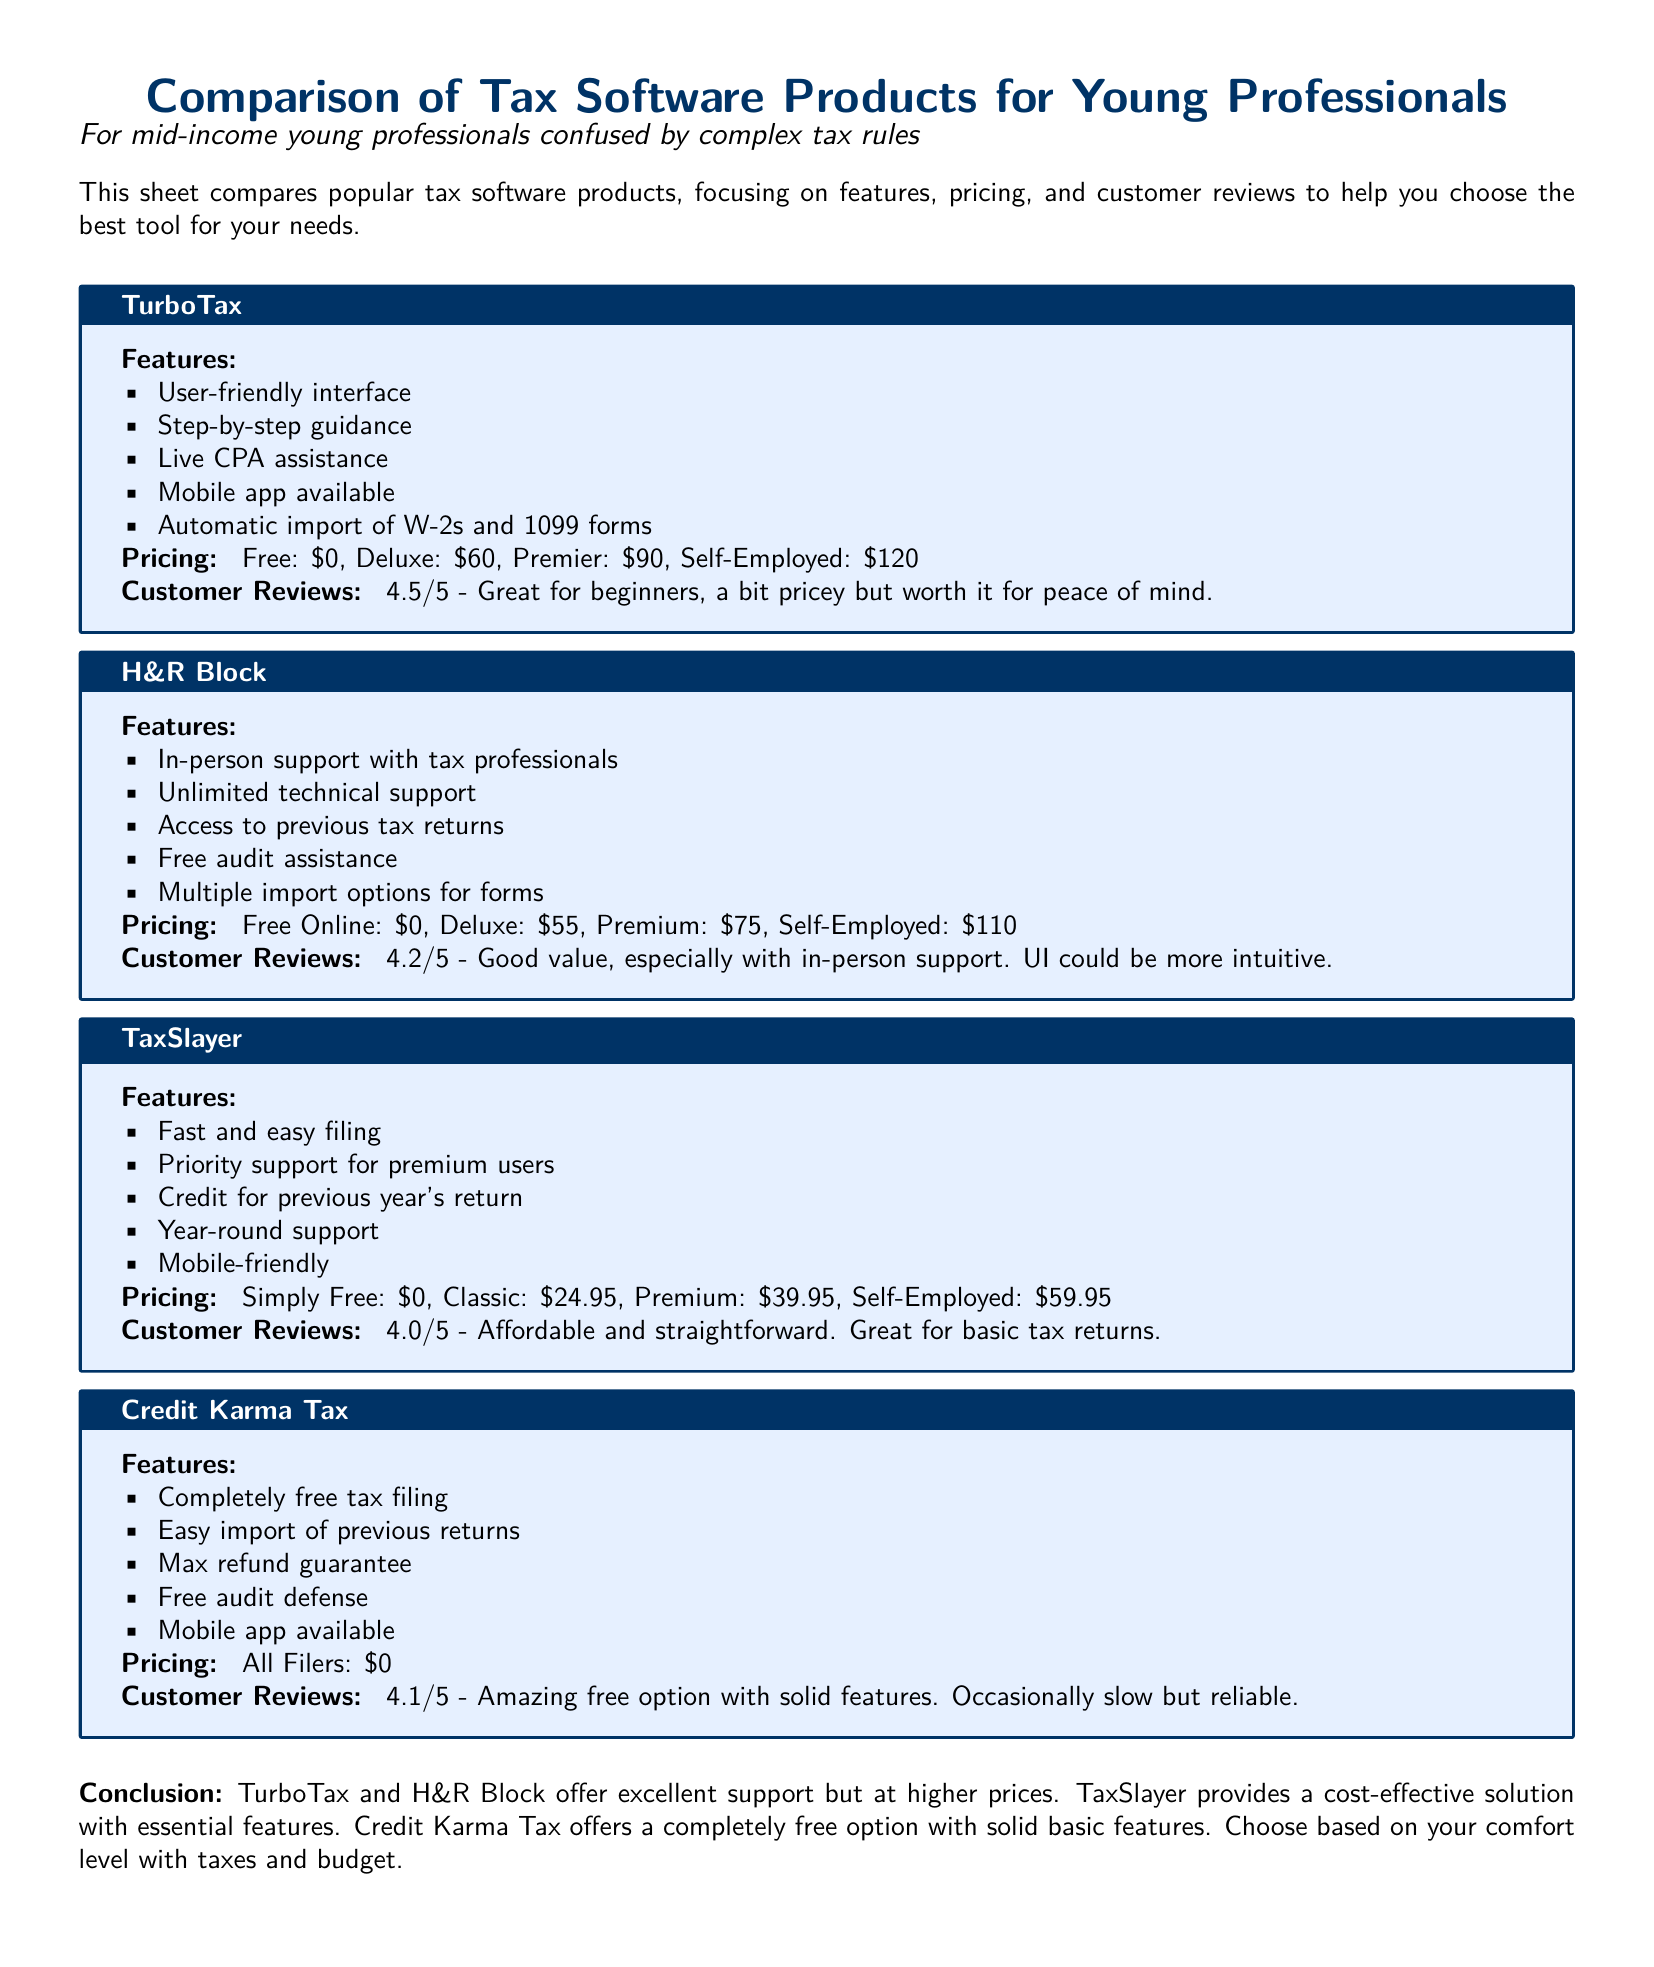What is the rating of TurboTax? The rating is mentioned in the customer reviews section for TurboTax, which is 4.5 out of 5.
Answer: 4.5/5 How much does H&R Block's Premium version cost? The price for H&R Block's Premium version is listed as $75 in the pricing section.
Answer: $75 What feature does Credit Karma Tax offer related to audits? The document states that Credit Karma Tax offers free audit defense, which is mentioned in its features list.
Answer: Free audit defense What is the lowest price option provided by TaxSlayer? The lowest price option for TaxSlayer is mentioned in the pricing section, which is $0 for Simply Free.
Answer: $0 Which software provides live CPA assistance? The features listed for TurboTax indicate that it offers live CPA assistance.
Answer: TurboTax What is the overall impression of TaxSlayer based on customer reviews? The customer reviews section rates TaxSlayer at 4.0 out of 5, indicating it is affordable and straightforward.
Answer: Affordable and straightforward Which tax software has in-person support available? The document states that H&R Block provides in-person support with tax professionals.
Answer: H&R Block Which product is completely free for all filers? According to the pricing section for Credit Karma Tax, it states that all filers can use it for free.
Answer: Credit Karma Tax 